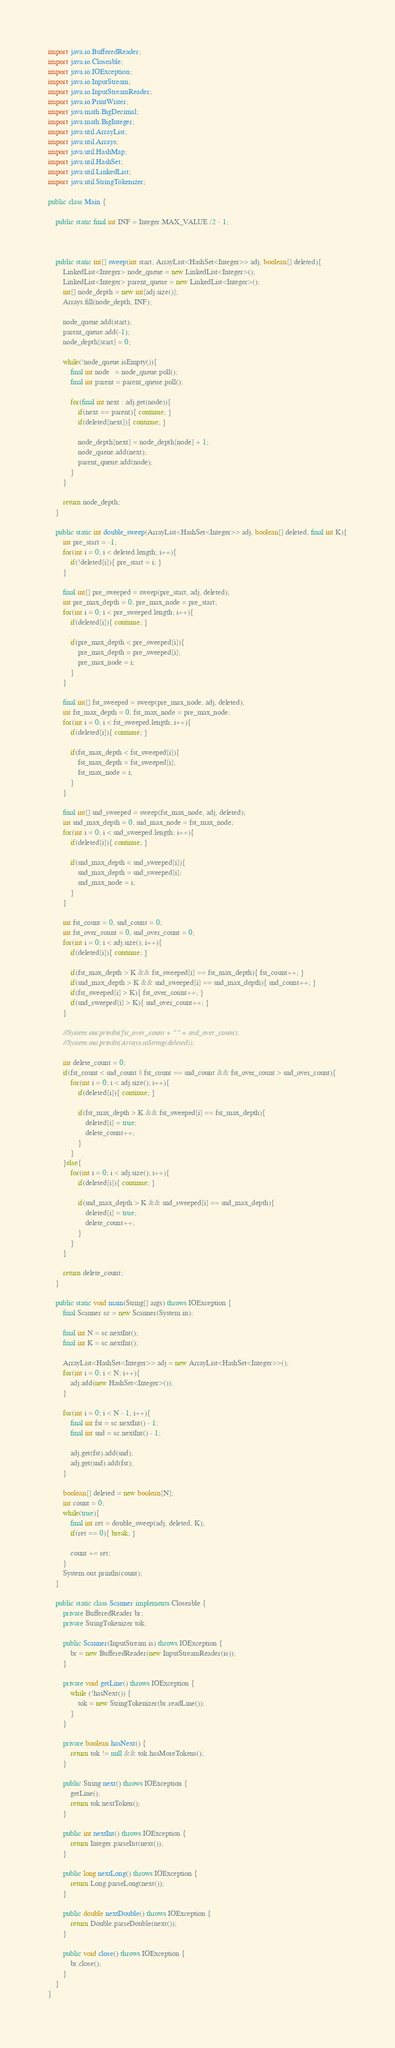Convert code to text. <code><loc_0><loc_0><loc_500><loc_500><_Java_>import java.io.BufferedReader;
import java.io.Closeable;
import java.io.IOException;
import java.io.InputStream;
import java.io.InputStreamReader;
import java.io.PrintWriter;
import java.math.BigDecimal;
import java.math.BigInteger;
import java.util.ArrayList;
import java.util.Arrays;
import java.util.HashMap;
import java.util.HashSet;
import java.util.LinkedList;
import java.util.StringTokenizer;
 
public class Main {
	
	public static final int INF = Integer.MAX_VALUE /2 - 1;
	
	
	
	public static int[] sweep(int start, ArrayList<HashSet<Integer>> adj, boolean[] deleted){
		LinkedList<Integer> node_queue = new LinkedList<Integer>();
		LinkedList<Integer> parent_queue = new LinkedList<Integer>();
		int[] node_depth = new int[adj.size()];
		Arrays.fill(node_depth, INF);
		
		node_queue.add(start);
		parent_queue.add(-1);
		node_depth[start] = 0;
		
		while(!node_queue.isEmpty()){
			final int node   = node_queue.poll();
			final int parent = parent_queue.poll();
			
			for(final int next : adj.get(node)){
				if(next == parent){ continue; }
				if(deleted[next]){ continue; }
				
				node_depth[next] = node_depth[node] + 1;
				node_queue.add(next);
				parent_queue.add(node);
			}
		}
		
		return node_depth;
	}
	
	public static int double_sweep(ArrayList<HashSet<Integer>> adj, boolean[] deleted, final int K){
		int pre_start = -1;
		for(int i = 0; i < deleted.length; i++){
			if(!deleted[i]){ pre_start = i; }
		}
		
		final int[] pre_sweeped = sweep(pre_start, adj, deleted);
		int pre_max_depth = 0, pre_max_node = pre_start;
		for(int i = 0; i < pre_sweeped.length; i++){
			if(deleted[i]){ continue; }
			
			if(pre_max_depth < pre_sweeped[i]){
				pre_max_depth = pre_sweeped[i];
				pre_max_node = i;
			}
		}
		
		final int[] fst_sweeped = sweep(pre_max_node, adj, deleted);
		int fst_max_depth = 0, fst_max_node = pre_max_node;
		for(int i = 0; i < fst_sweeped.length; i++){
			if(deleted[i]){ continue; }
			
			if(fst_max_depth < fst_sweeped[i]){
				fst_max_depth = fst_sweeped[i];
				fst_max_node = i;
			}
		}
		
		final int[] snd_sweeped = sweep(fst_max_node, adj, deleted);
		int snd_max_depth = 0, snd_max_node = fst_max_node;
		for(int i = 0; i < snd_sweeped.length; i++){
			if(deleted[i]){ continue; }
			
			if(snd_max_depth < snd_sweeped[i]){
				snd_max_depth = snd_sweeped[i];
				snd_max_node = i;
			}
		}
		
		int fst_count = 0, snd_count = 0;
		int fst_over_count = 0, snd_over_count = 0;
		for(int i = 0; i < adj.size(); i++){
			if(deleted[i]){ continue; }
			
			if(fst_max_depth > K && fst_sweeped[i] == fst_max_depth){ fst_count++; }
			if(snd_max_depth > K && snd_sweeped[i] == snd_max_depth){ snd_count++; }
			if(fst_sweeped[i] > K){ fst_over_count++; }
			if(snd_sweeped[i] > K){ snd_over_count++; }
		}
		
		//System.out.println(fst_over_count + " " + snd_over_count);
		//System.out.println(Arrays.toString(deleted));
		
		int delete_count = 0;
		if(fst_count < snd_count || fst_count == snd_count && fst_over_count > snd_over_count){
			for(int i = 0; i < adj.size(); i++){
				if(deleted[i]){ continue; }
				
				if(fst_max_depth > K && fst_sweeped[i] == fst_max_depth){ 
					deleted[i] = true;
					delete_count++;
				}
			}
		}else{
			for(int i = 0; i < adj.size(); i++){
				if(deleted[i]){ continue; }
				
				if(snd_max_depth > K && snd_sweeped[i] == snd_max_depth){
					deleted[i] = true;
					delete_count++;
				}
			}
		}
		
		return delete_count;
	}
	
	public static void main(String[] args) throws IOException {
		final Scanner sc = new Scanner(System.in);
		
		final int N = sc.nextInt();
		final int K = sc.nextInt();
		
		ArrayList<HashSet<Integer>> adj = new ArrayList<HashSet<Integer>>();
		for(int i = 0; i < N; i++){
			adj.add(new HashSet<Integer>());
		}
		
		for(int i = 0; i < N - 1; i++){
			final int fst = sc.nextInt() - 1;
			final int snd = sc.nextInt() - 1;
			
			adj.get(fst).add(snd);
			adj.get(snd).add(fst);
		}
		
		boolean[] deleted = new boolean[N];
		int count = 0;
		while(true){
			final int ret = double_sweep(adj, deleted, K);
			if(ret == 0){ break; }
			
			count += ret;
		}
		System.out.println(count);
	}
 
	public static class Scanner implements Closeable {
		private BufferedReader br;
		private StringTokenizer tok;
 
		public Scanner(InputStream is) throws IOException {
			br = new BufferedReader(new InputStreamReader(is));
		}
 
		private void getLine() throws IOException {
			while (!hasNext()) {
				tok = new StringTokenizer(br.readLine());
			}
		}
 
		private boolean hasNext() {
			return tok != null && tok.hasMoreTokens();
		}
 
		public String next() throws IOException {
			getLine();
			return tok.nextToken();
		}
 
		public int nextInt() throws IOException {
			return Integer.parseInt(next());
		}
 
		public long nextLong() throws IOException {
			return Long.parseLong(next());
		}
 
		public double nextDouble() throws IOException {
			return Double.parseDouble(next());
		}
 
		public void close() throws IOException {
			br.close();
		}
	}
}</code> 